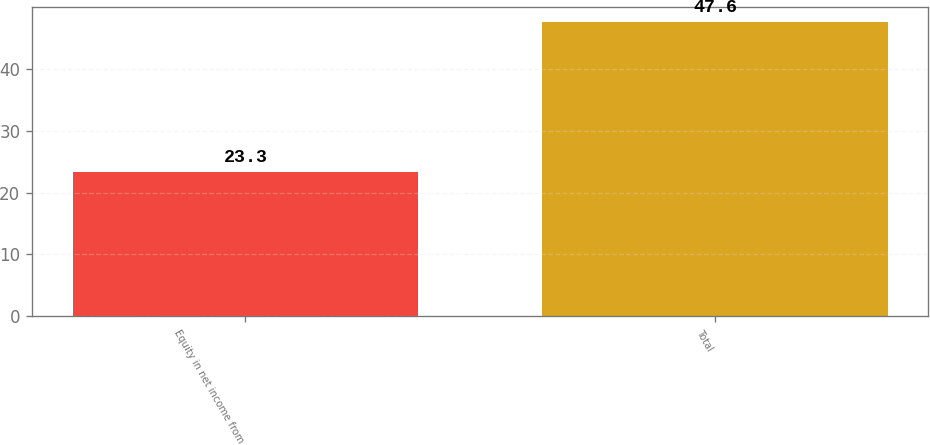<chart> <loc_0><loc_0><loc_500><loc_500><bar_chart><fcel>Equity in net income from<fcel>Total<nl><fcel>23.3<fcel>47.6<nl></chart> 